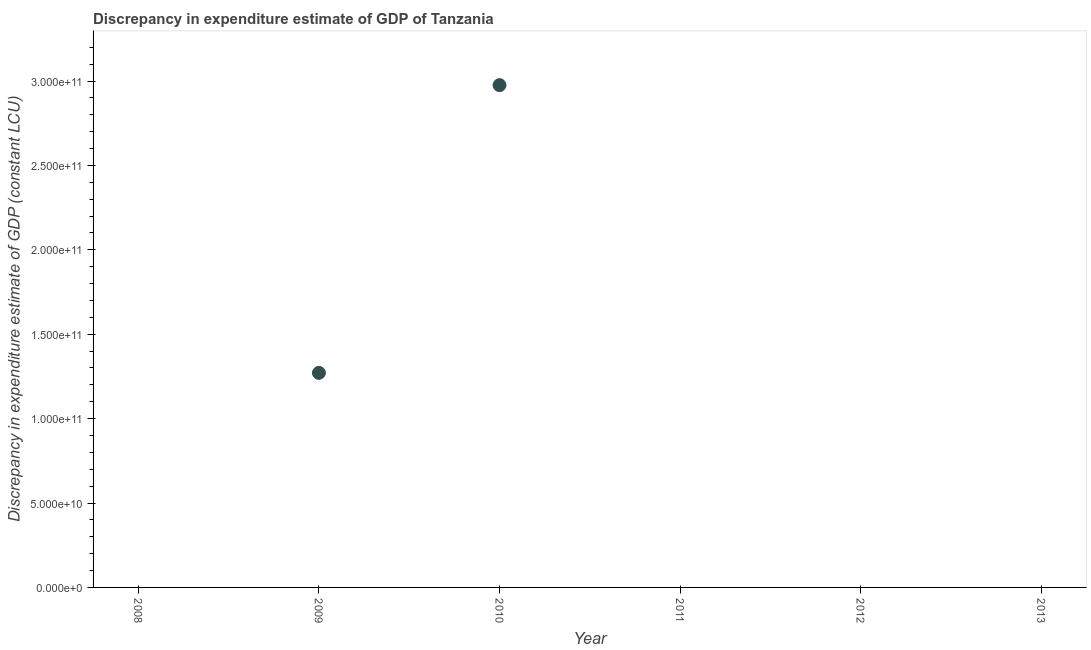What is the discrepancy in expenditure estimate of gdp in 2010?
Provide a short and direct response. 2.98e+11. Across all years, what is the maximum discrepancy in expenditure estimate of gdp?
Provide a succinct answer. 2.98e+11. Across all years, what is the minimum discrepancy in expenditure estimate of gdp?
Keep it short and to the point. 0. What is the sum of the discrepancy in expenditure estimate of gdp?
Make the answer very short. 4.25e+11. What is the difference between the discrepancy in expenditure estimate of gdp in 2009 and 2010?
Your answer should be very brief. -1.70e+11. What is the average discrepancy in expenditure estimate of gdp per year?
Your answer should be very brief. 7.08e+1. What is the median discrepancy in expenditure estimate of gdp?
Your response must be concise. 0. In how many years, is the discrepancy in expenditure estimate of gdp greater than 260000000000 LCU?
Your answer should be compact. 1. What is the difference between the highest and the lowest discrepancy in expenditure estimate of gdp?
Keep it short and to the point. 2.98e+11. How many dotlines are there?
Your answer should be very brief. 1. How many years are there in the graph?
Provide a succinct answer. 6. Are the values on the major ticks of Y-axis written in scientific E-notation?
Make the answer very short. Yes. Does the graph contain any zero values?
Your response must be concise. Yes. What is the title of the graph?
Offer a very short reply. Discrepancy in expenditure estimate of GDP of Tanzania. What is the label or title of the Y-axis?
Your answer should be very brief. Discrepancy in expenditure estimate of GDP (constant LCU). What is the Discrepancy in expenditure estimate of GDP (constant LCU) in 2008?
Offer a very short reply. 0. What is the Discrepancy in expenditure estimate of GDP (constant LCU) in 2009?
Offer a terse response. 1.27e+11. What is the Discrepancy in expenditure estimate of GDP (constant LCU) in 2010?
Keep it short and to the point. 2.98e+11. What is the difference between the Discrepancy in expenditure estimate of GDP (constant LCU) in 2009 and 2010?
Provide a short and direct response. -1.70e+11. What is the ratio of the Discrepancy in expenditure estimate of GDP (constant LCU) in 2009 to that in 2010?
Provide a short and direct response. 0.43. 